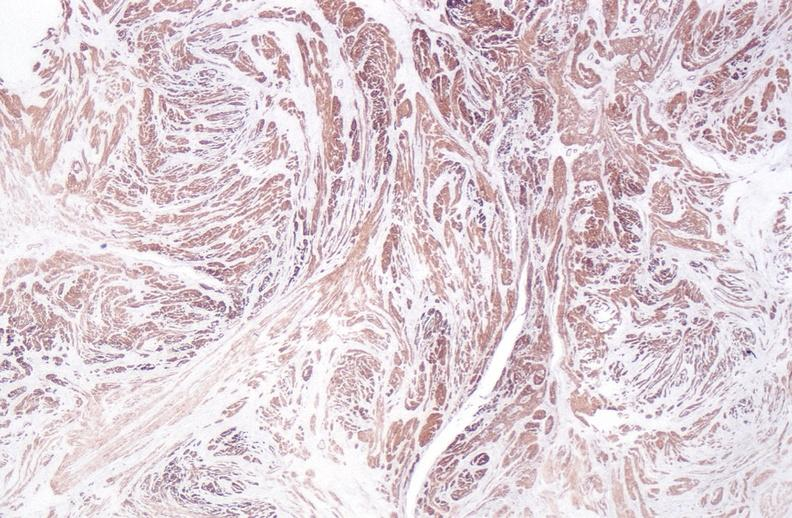does heel ulcer show leiomyoma?
Answer the question using a single word or phrase. No 